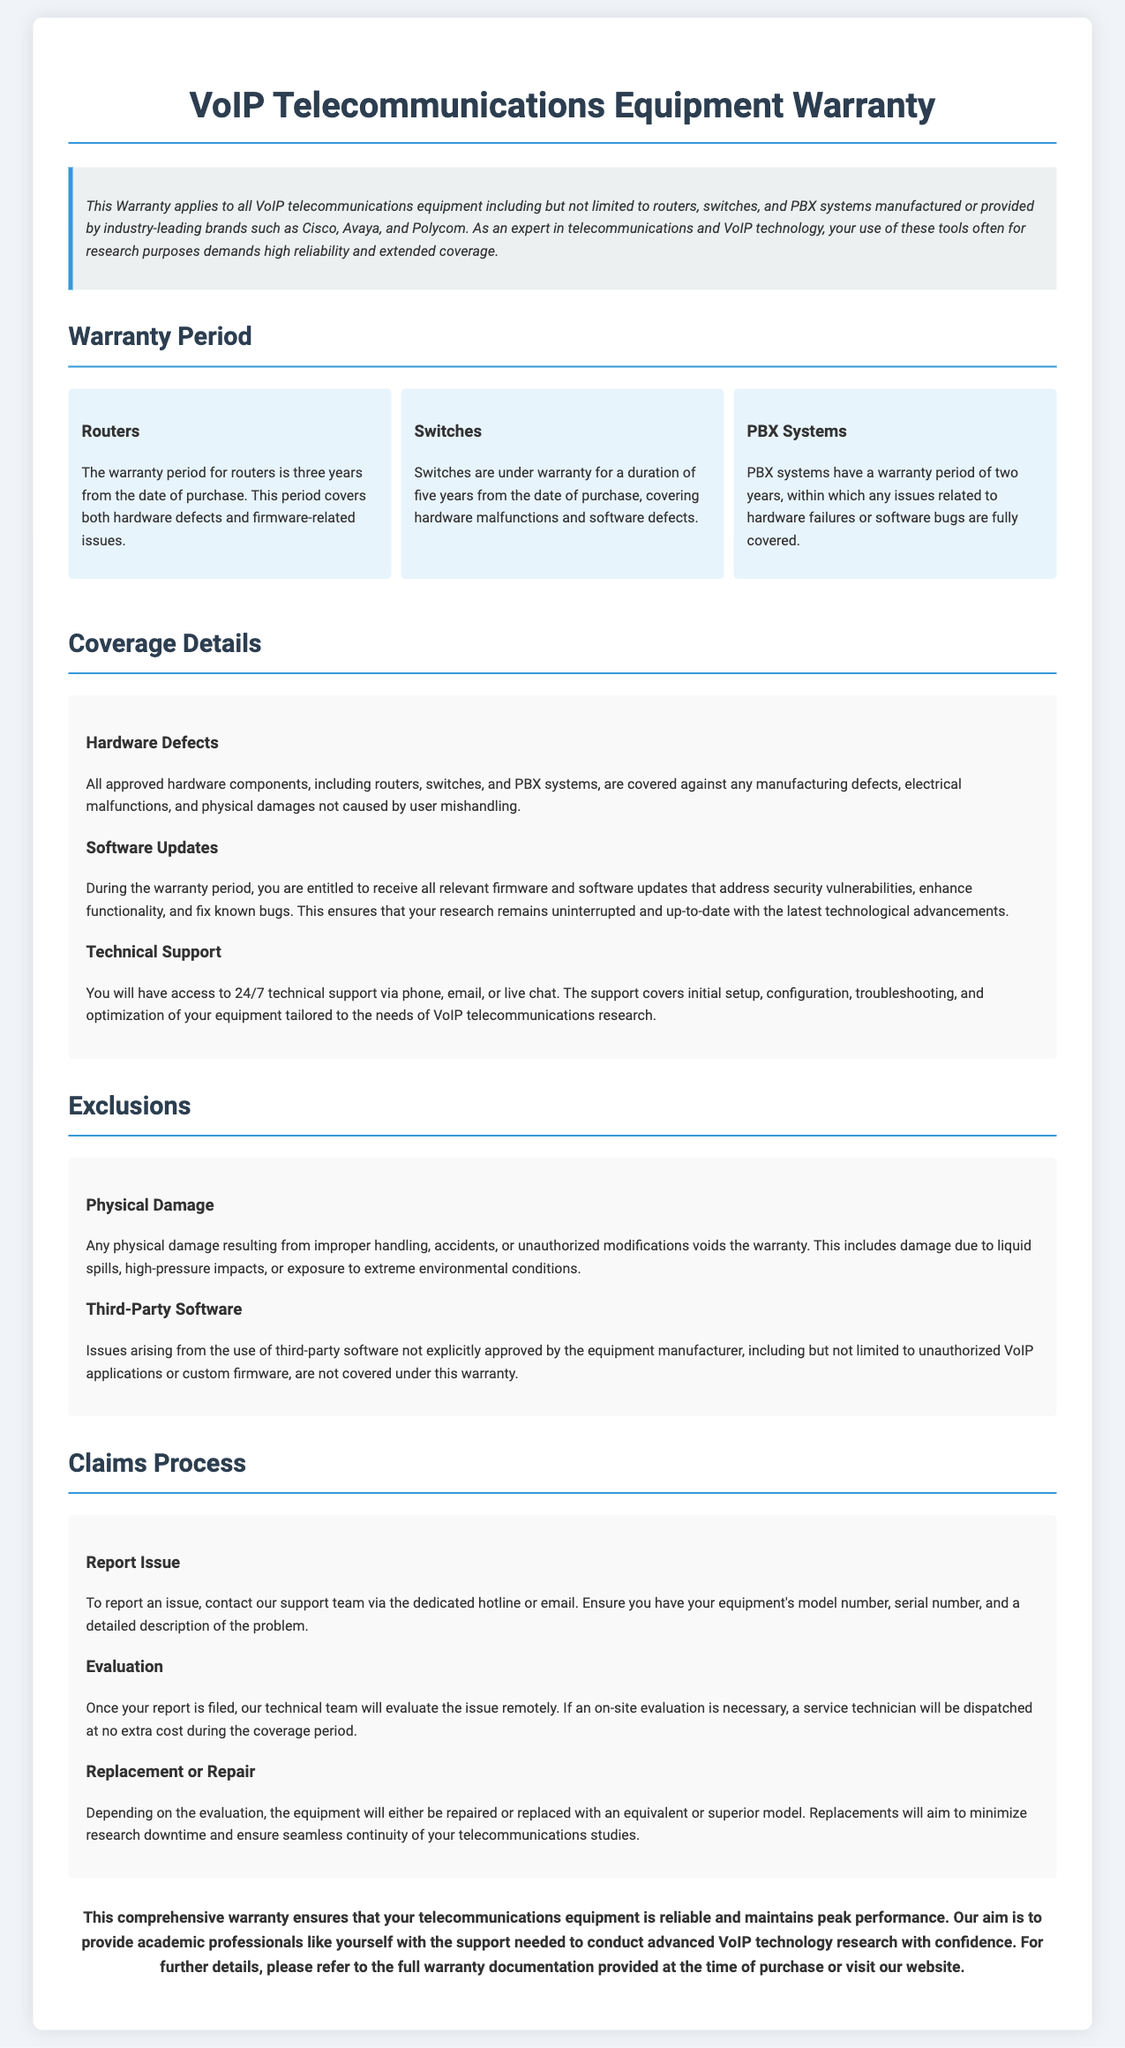What is the warranty period for routers? The warranty period for routers is stated as three years from the date of purchase.
Answer: three years How long are switches covered under warranty? The document specifies that switches are under warranty for five years from the date of purchase.
Answer: five years What types of defects are covered under hardware defects? Hardware defects include manufacturing defects, electrical malfunctions, and physical damages not caused by user mishandling.
Answer: manufacturing defects, electrical malfunctions, physical damages What kind of support is provided during the warranty period? The document mentions 24/7 technical support via phone, email, or live chat for the covered equipment.
Answer: 24/7 technical support What voids the warranty regarding physical damage? The warranty is voided by physical damage resulting from improper handling, accidents, or unauthorized modifications.
Answer: improper handling, accidents, unauthorized modifications What should you have ready when reporting an issue? According to the claims process, you should have your equipment's model number, serial number, and a detailed description of the problem.
Answer: model number, serial number, detailed description How will the equipment be addressed if a claim is approved? The process states that the equipment will either be repaired or replaced with an equivalent or superior model if the claim is approved.
Answer: repaired or replaced What is specifically excluded from the warranty regarding software? The warranty explicitly states that issues arising from the use of third-party software not approved by the manufacturer are excluded.
Answer: third-party software Which types of VoIP equipment are covered under this warranty? The document mentions that the warranty applies to all VoIP telecommunications equipment including routers, switches, and PBX systems.
Answer: routers, switches, PBX systems 